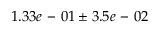<formula> <loc_0><loc_0><loc_500><loc_500>1 . 3 3 e - 0 1 \pm 3 . 5 e - 0 2</formula> 